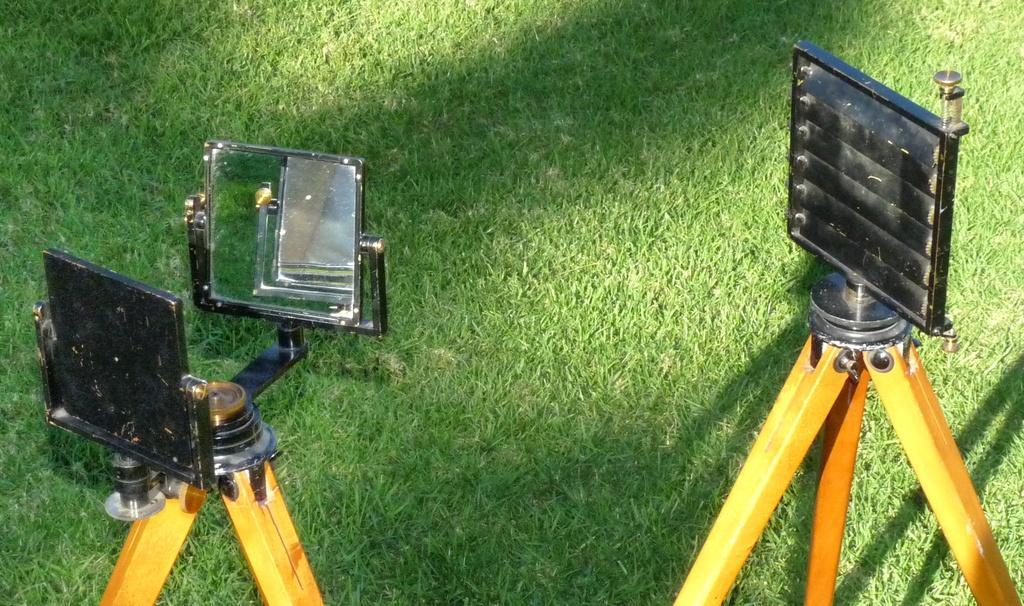Please provide a concise description of this image. In this image we can see two stands on the ground, also we can see the grass. 